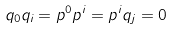Convert formula to latex. <formula><loc_0><loc_0><loc_500><loc_500>q _ { 0 } q _ { i } = p ^ { 0 } p ^ { i } = p ^ { i } q _ { j } = 0</formula> 